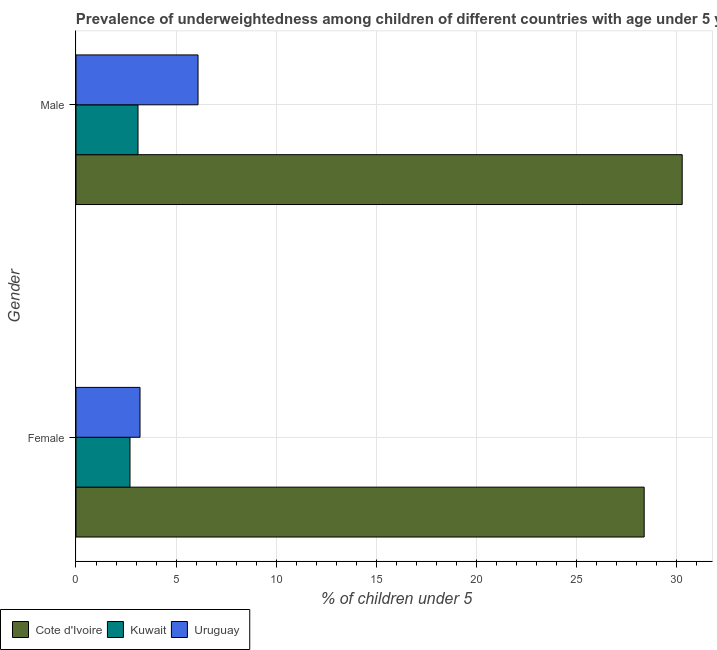Are the number of bars per tick equal to the number of legend labels?
Make the answer very short. Yes. What is the label of the 1st group of bars from the top?
Provide a short and direct response. Male. What is the percentage of underweighted female children in Uruguay?
Keep it short and to the point. 3.2. Across all countries, what is the maximum percentage of underweighted female children?
Keep it short and to the point. 28.4. Across all countries, what is the minimum percentage of underweighted female children?
Your response must be concise. 2.7. In which country was the percentage of underweighted female children maximum?
Offer a very short reply. Cote d'Ivoire. In which country was the percentage of underweighted female children minimum?
Ensure brevity in your answer.  Kuwait. What is the total percentage of underweighted male children in the graph?
Your answer should be compact. 39.5. What is the difference between the percentage of underweighted male children in Uruguay and that in Kuwait?
Ensure brevity in your answer.  3. What is the difference between the percentage of underweighted male children in Uruguay and the percentage of underweighted female children in Kuwait?
Offer a very short reply. 3.4. What is the average percentage of underweighted male children per country?
Ensure brevity in your answer.  13.17. What is the difference between the percentage of underweighted male children and percentage of underweighted female children in Uruguay?
Keep it short and to the point. 2.9. In how many countries, is the percentage of underweighted male children greater than 3 %?
Ensure brevity in your answer.  3. What is the ratio of the percentage of underweighted female children in Cote d'Ivoire to that in Kuwait?
Make the answer very short. 10.52. In how many countries, is the percentage of underweighted female children greater than the average percentage of underweighted female children taken over all countries?
Offer a very short reply. 1. What does the 1st bar from the top in Female represents?
Give a very brief answer. Uruguay. What does the 1st bar from the bottom in Male represents?
Your answer should be very brief. Cote d'Ivoire. How many countries are there in the graph?
Keep it short and to the point. 3. Are the values on the major ticks of X-axis written in scientific E-notation?
Keep it short and to the point. No. Does the graph contain grids?
Ensure brevity in your answer.  Yes. How many legend labels are there?
Provide a succinct answer. 3. How are the legend labels stacked?
Your answer should be very brief. Horizontal. What is the title of the graph?
Your answer should be very brief. Prevalence of underweightedness among children of different countries with age under 5 years. What is the label or title of the X-axis?
Offer a terse response.  % of children under 5. What is the label or title of the Y-axis?
Your answer should be very brief. Gender. What is the  % of children under 5 in Cote d'Ivoire in Female?
Offer a terse response. 28.4. What is the  % of children under 5 in Kuwait in Female?
Give a very brief answer. 2.7. What is the  % of children under 5 in Uruguay in Female?
Provide a succinct answer. 3.2. What is the  % of children under 5 of Cote d'Ivoire in Male?
Offer a terse response. 30.3. What is the  % of children under 5 in Kuwait in Male?
Keep it short and to the point. 3.1. What is the  % of children under 5 in Uruguay in Male?
Your answer should be very brief. 6.1. Across all Gender, what is the maximum  % of children under 5 of Cote d'Ivoire?
Offer a terse response. 30.3. Across all Gender, what is the maximum  % of children under 5 of Kuwait?
Provide a succinct answer. 3.1. Across all Gender, what is the maximum  % of children under 5 in Uruguay?
Make the answer very short. 6.1. Across all Gender, what is the minimum  % of children under 5 of Cote d'Ivoire?
Offer a terse response. 28.4. Across all Gender, what is the minimum  % of children under 5 in Kuwait?
Ensure brevity in your answer.  2.7. Across all Gender, what is the minimum  % of children under 5 in Uruguay?
Provide a short and direct response. 3.2. What is the total  % of children under 5 of Cote d'Ivoire in the graph?
Your answer should be very brief. 58.7. What is the total  % of children under 5 of Uruguay in the graph?
Keep it short and to the point. 9.3. What is the difference between the  % of children under 5 of Cote d'Ivoire in Female and that in Male?
Give a very brief answer. -1.9. What is the difference between the  % of children under 5 of Uruguay in Female and that in Male?
Provide a succinct answer. -2.9. What is the difference between the  % of children under 5 in Cote d'Ivoire in Female and the  % of children under 5 in Kuwait in Male?
Give a very brief answer. 25.3. What is the difference between the  % of children under 5 of Cote d'Ivoire in Female and the  % of children under 5 of Uruguay in Male?
Keep it short and to the point. 22.3. What is the difference between the  % of children under 5 of Kuwait in Female and the  % of children under 5 of Uruguay in Male?
Make the answer very short. -3.4. What is the average  % of children under 5 of Cote d'Ivoire per Gender?
Your answer should be compact. 29.35. What is the average  % of children under 5 in Uruguay per Gender?
Give a very brief answer. 4.65. What is the difference between the  % of children under 5 in Cote d'Ivoire and  % of children under 5 in Kuwait in Female?
Offer a very short reply. 25.7. What is the difference between the  % of children under 5 of Cote d'Ivoire and  % of children under 5 of Uruguay in Female?
Offer a very short reply. 25.2. What is the difference between the  % of children under 5 in Kuwait and  % of children under 5 in Uruguay in Female?
Your answer should be very brief. -0.5. What is the difference between the  % of children under 5 of Cote d'Ivoire and  % of children under 5 of Kuwait in Male?
Keep it short and to the point. 27.2. What is the difference between the  % of children under 5 in Cote d'Ivoire and  % of children under 5 in Uruguay in Male?
Offer a terse response. 24.2. What is the difference between the  % of children under 5 in Kuwait and  % of children under 5 in Uruguay in Male?
Keep it short and to the point. -3. What is the ratio of the  % of children under 5 in Cote d'Ivoire in Female to that in Male?
Make the answer very short. 0.94. What is the ratio of the  % of children under 5 of Kuwait in Female to that in Male?
Your answer should be very brief. 0.87. What is the ratio of the  % of children under 5 of Uruguay in Female to that in Male?
Offer a very short reply. 0.52. What is the difference between the highest and the lowest  % of children under 5 in Cote d'Ivoire?
Your answer should be compact. 1.9. What is the difference between the highest and the lowest  % of children under 5 in Kuwait?
Your answer should be compact. 0.4. What is the difference between the highest and the lowest  % of children under 5 in Uruguay?
Offer a terse response. 2.9. 